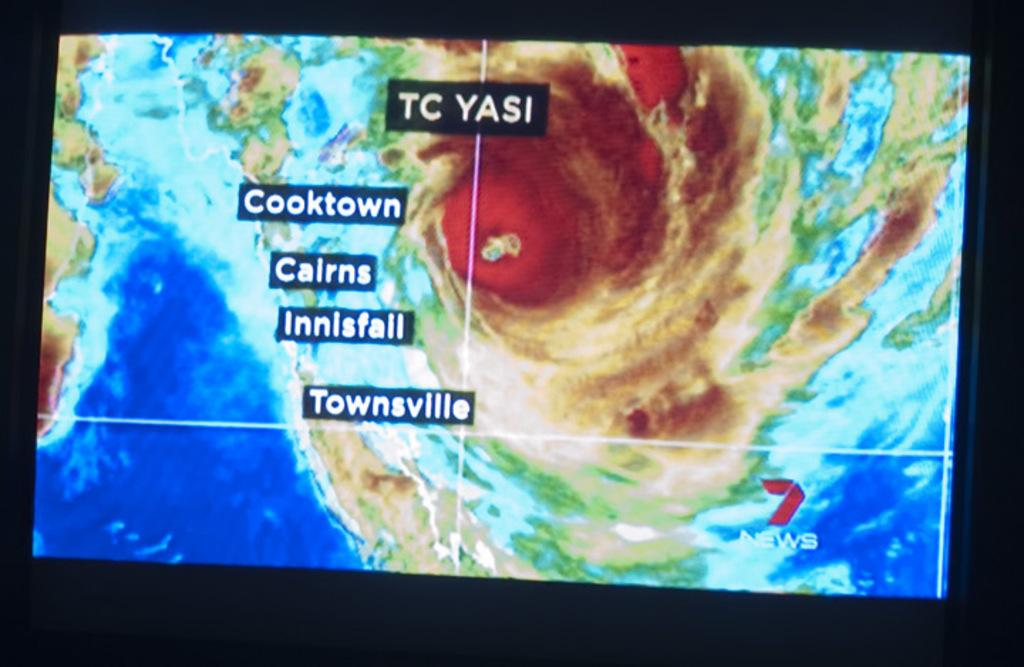<image>
Write a terse but informative summary of the picture. Screen showing a natural disaster and the words "TC YASI" on top. 